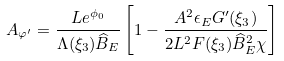<formula> <loc_0><loc_0><loc_500><loc_500>A _ { \varphi ^ { \prime } } = \frac { L e ^ { \phi _ { 0 } } } { \Lambda ( \xi _ { 3 } ) \widehat { B } _ { E } } \left [ 1 - \frac { A ^ { 2 } \epsilon _ { E } G ^ { \prime } ( \xi _ { 3 } ) } { 2 L ^ { 2 } F ( \xi _ { 3 } ) \widehat { B } _ { E } ^ { 2 } \chi } \right ]</formula> 